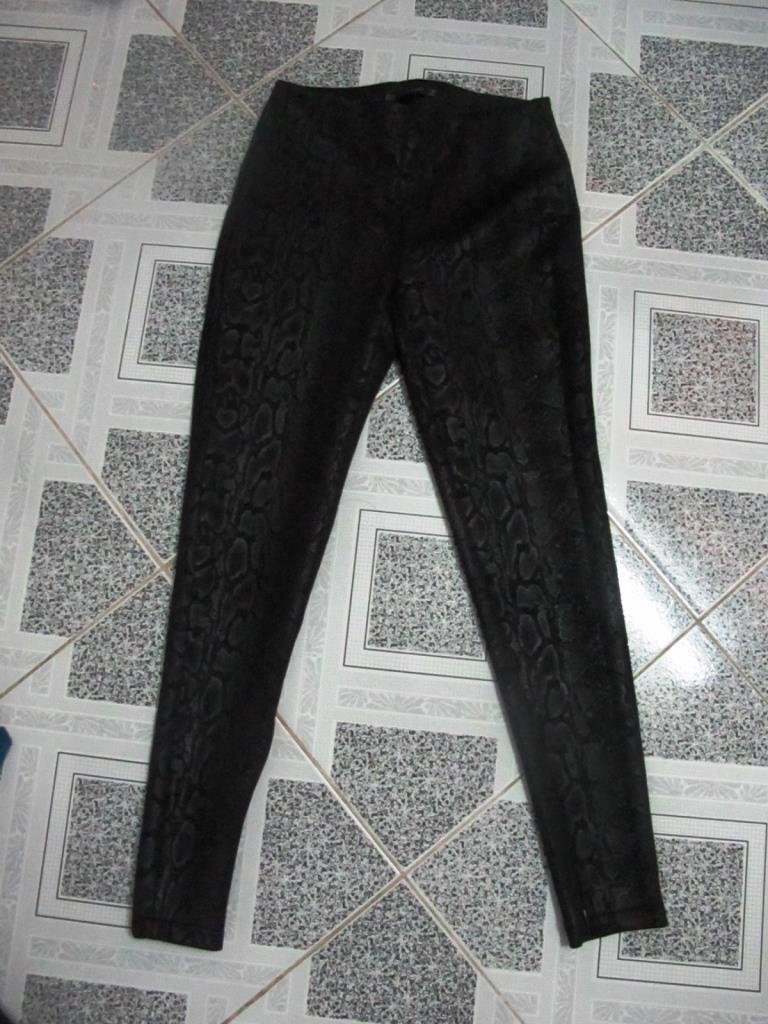What type of flooring is visible in the image? The image contains black and white color tiles. What type of clothing is present in the image? There is a black pant in the image. How many pets are visible in the image? There are no pets present in the image. What type of room is shown in the image? The image does not show a room; it only contains black and white color tiles and a black pant. 